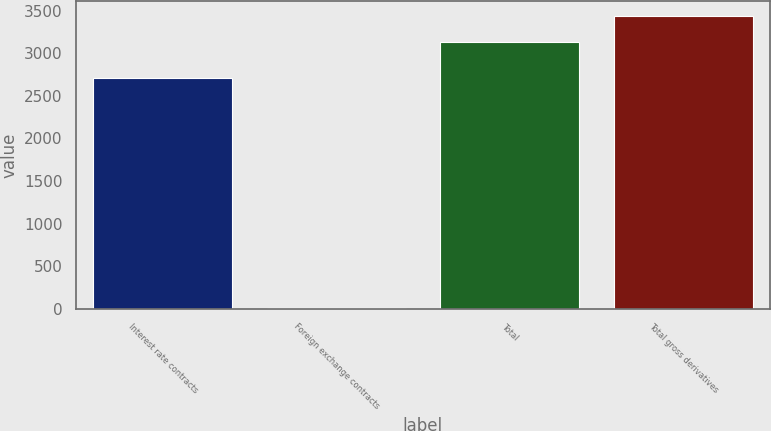Convert chart to OTSL. <chart><loc_0><loc_0><loc_500><loc_500><bar_chart><fcel>Interest rate contracts<fcel>Foreign exchange contracts<fcel>Total<fcel>Total gross derivatives<nl><fcel>2714<fcel>9<fcel>3129<fcel>3441<nl></chart> 